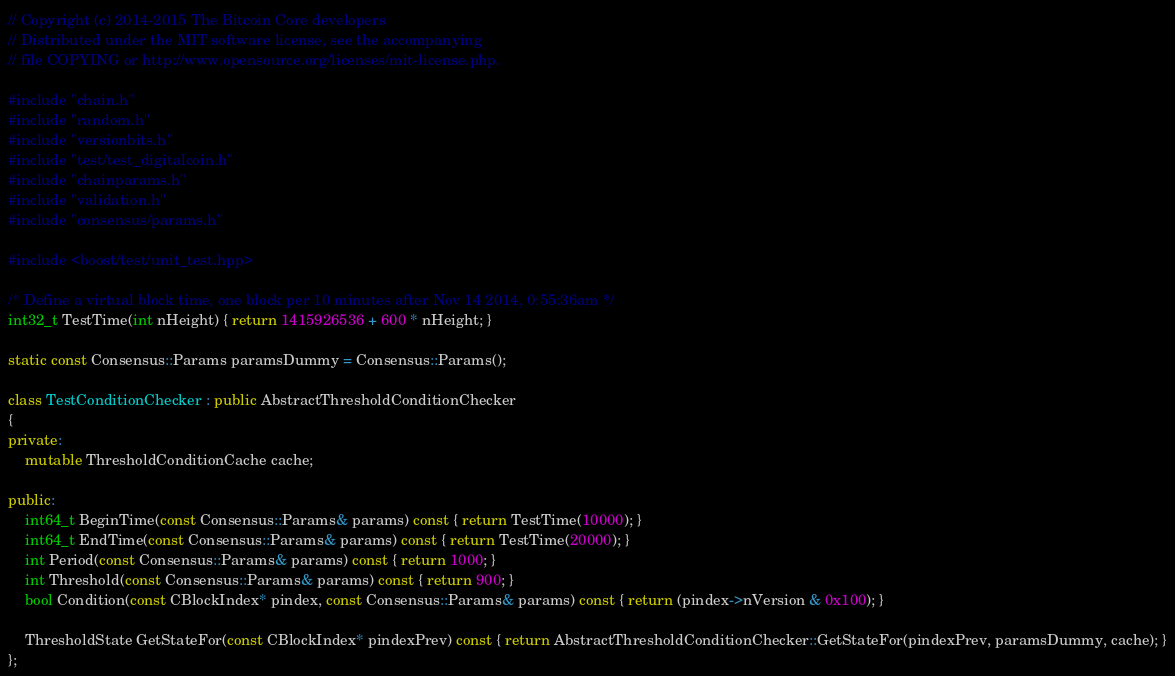<code> <loc_0><loc_0><loc_500><loc_500><_C++_>// Copyright (c) 2014-2015 The Bitcoin Core developers
// Distributed under the MIT software license, see the accompanying
// file COPYING or http://www.opensource.org/licenses/mit-license.php.

#include "chain.h"
#include "random.h"
#include "versionbits.h"
#include "test/test_digitalcoin.h"
#include "chainparams.h"
#include "validation.h"
#include "consensus/params.h"

#include <boost/test/unit_test.hpp>

/* Define a virtual block time, one block per 10 minutes after Nov 14 2014, 0:55:36am */
int32_t TestTime(int nHeight) { return 1415926536 + 600 * nHeight; }

static const Consensus::Params paramsDummy = Consensus::Params();

class TestConditionChecker : public AbstractThresholdConditionChecker
{
private:
    mutable ThresholdConditionCache cache;

public:
    int64_t BeginTime(const Consensus::Params& params) const { return TestTime(10000); }
    int64_t EndTime(const Consensus::Params& params) const { return TestTime(20000); }
    int Period(const Consensus::Params& params) const { return 1000; }
    int Threshold(const Consensus::Params& params) const { return 900; }
    bool Condition(const CBlockIndex* pindex, const Consensus::Params& params) const { return (pindex->nVersion & 0x100); }

    ThresholdState GetStateFor(const CBlockIndex* pindexPrev) const { return AbstractThresholdConditionChecker::GetStateFor(pindexPrev, paramsDummy, cache); }
};
</code> 